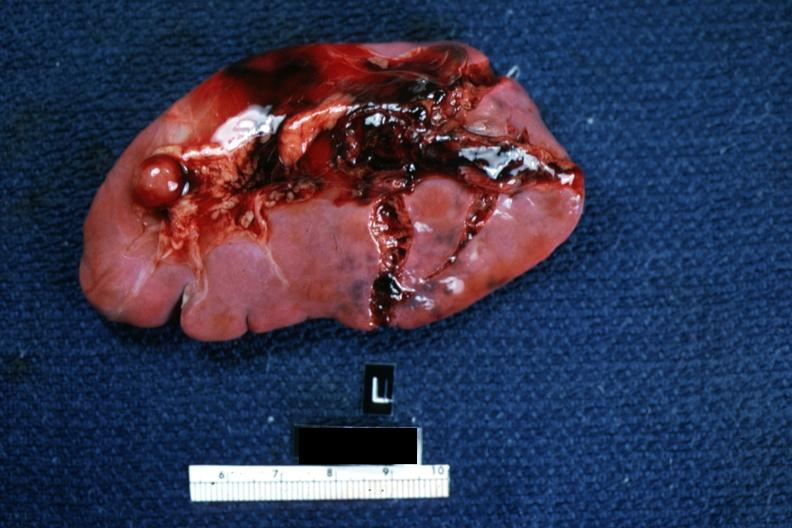what does this image show?
Answer the question using a single word or phrase. Typical lacerations 